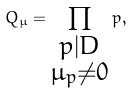<formula> <loc_0><loc_0><loc_500><loc_500>Q _ { \mu } = \prod _ { \substack { p | D \\ \mu _ { p } \neq 0 } } p ,</formula> 